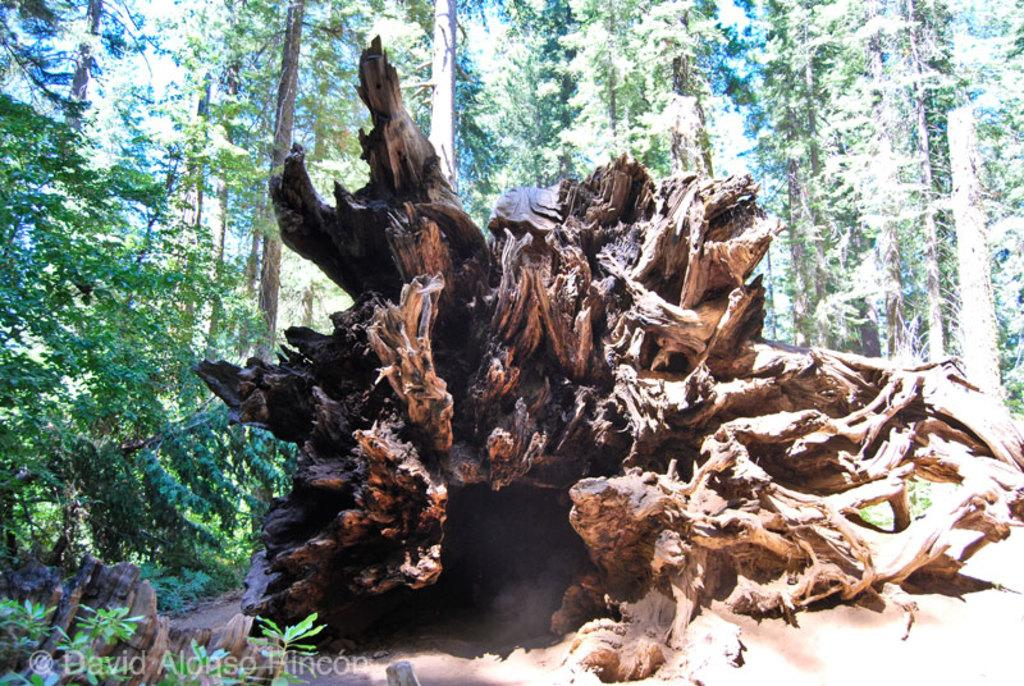What is the main subject of the image? The main subject of the image is wood at the center. Can you describe the background of the image? There are trees in the background of the image. What type of plot is being developed in the downtown area in the image? There is no reference to a plot or downtown area in the image; it features wood at the center and trees in the background. 